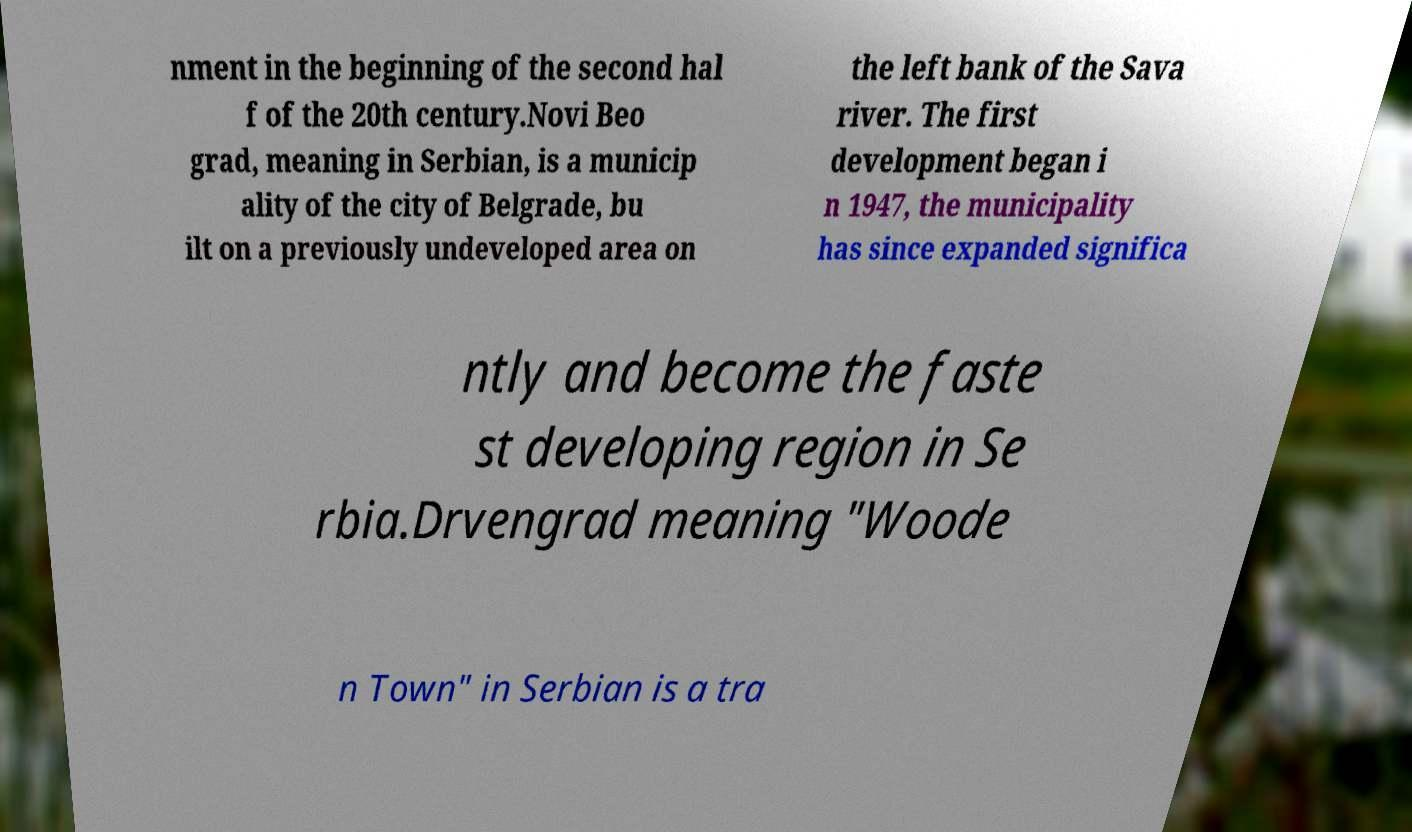Could you assist in decoding the text presented in this image and type it out clearly? nment in the beginning of the second hal f of the 20th century.Novi Beo grad, meaning in Serbian, is a municip ality of the city of Belgrade, bu ilt on a previously undeveloped area on the left bank of the Sava river. The first development began i n 1947, the municipality has since expanded significa ntly and become the faste st developing region in Se rbia.Drvengrad meaning "Woode n Town" in Serbian is a tra 